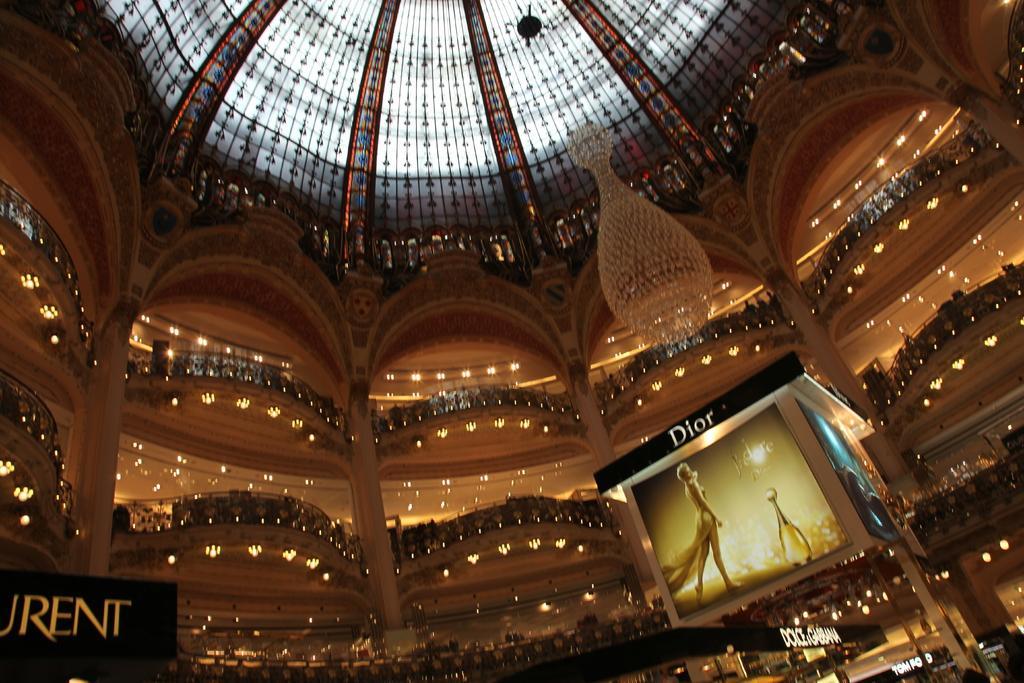Please provide a concise description of this image. This picture is clicked inside the hall. On the right we can see the pictures and some text on the banners. At the top we can see a chandelier hanging on the roof and we can see the lights and deck rails and the decoration lights and many other objects. 